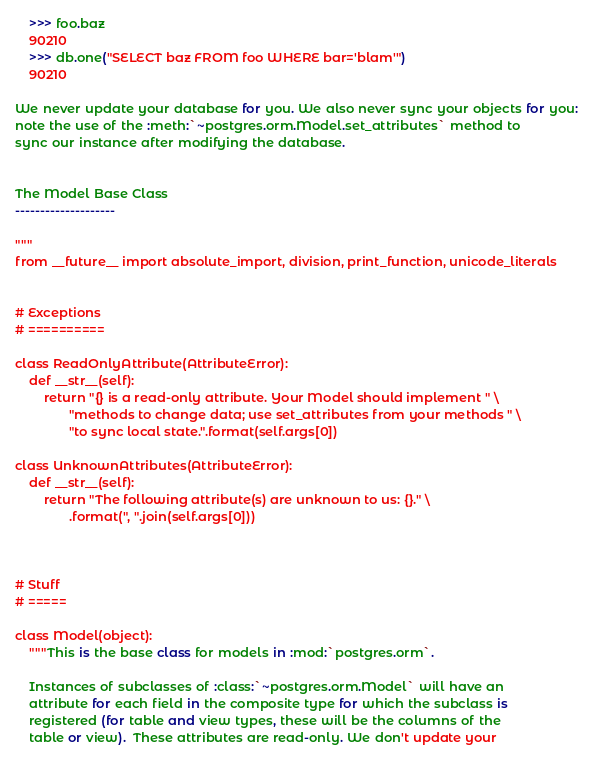Convert code to text. <code><loc_0><loc_0><loc_500><loc_500><_Python_>    >>> foo.baz
    90210
    >>> db.one("SELECT baz FROM foo WHERE bar='blam'")
    90210

We never update your database for you. We also never sync your objects for you:
note the use of the :meth:`~postgres.orm.Model.set_attributes` method to
sync our instance after modifying the database.


The Model Base Class
--------------------

"""
from __future__ import absolute_import, division, print_function, unicode_literals


# Exceptions
# ==========

class ReadOnlyAttribute(AttributeError):
    def __str__(self):
        return "{} is a read-only attribute. Your Model should implement " \
               "methods to change data; use set_attributes from your methods " \
               "to sync local state.".format(self.args[0])

class UnknownAttributes(AttributeError):
    def __str__(self):
        return "The following attribute(s) are unknown to us: {}." \
               .format(", ".join(self.args[0]))



# Stuff
# =====

class Model(object):
    """This is the base class for models in :mod:`postgres.orm`.

    Instances of subclasses of :class:`~postgres.orm.Model` will have an
    attribute for each field in the composite type for which the subclass is
    registered (for table and view types, these will be the columns of the
    table or view).  These attributes are read-only. We don't update your</code> 